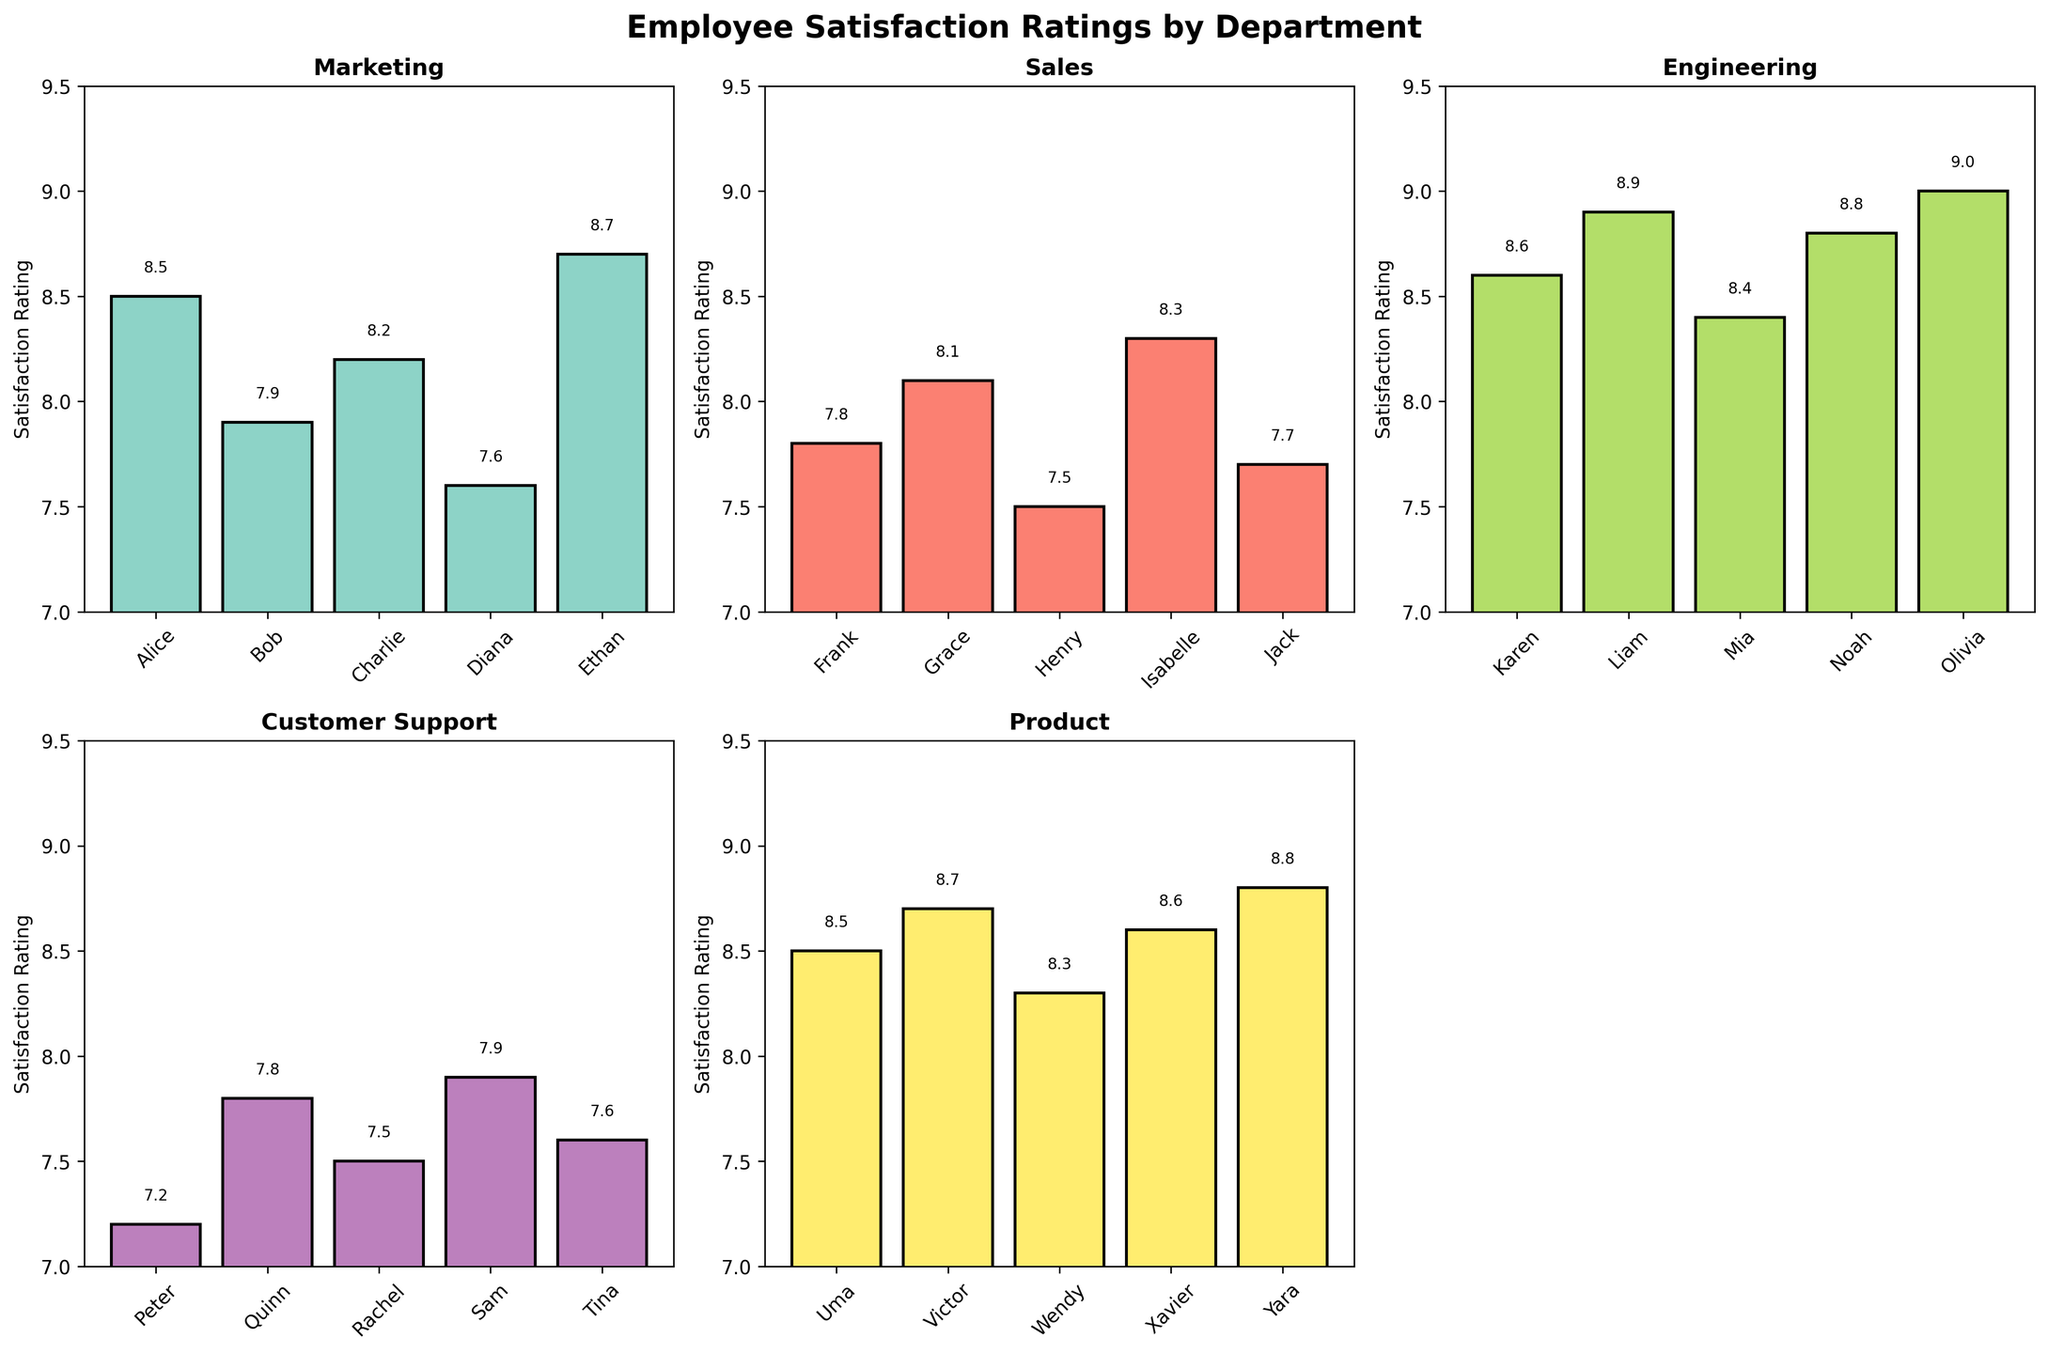Which department has the highest average satisfaction rating? Calculate the average satisfaction rating for each department: Marketing (8.18), Sales (7.88), Engineering (8.74), Customer Support (7.6), Product (8.58). Engineering has the highest average satisfaction rating.
Answer: Engineering Which employee has the highest satisfaction rating in the Customer Support department? In Customer Support, the satisfaction ratings are Peter (7.2), Quinn (7.8), Rachel (7.5), Sam (7.9), Tina (7.6). Sam has the highest rating.
Answer: Sam Compare the highest and lowest satisfaction ratings across all departments. Highest rating: Olivia in Engineering with 9.0. Lowest rating: Peter in Customer Support with 7.2.
Answer: 9.0 and 7.2 What is the difference between the average satisfaction ratings of Sales and Product departments? Calculate the averages: Sales (7.88) and Product (8.58). The difference is 8.58 - 7.88 = 0.7.
Answer: 0.7 How many departments have an average satisfaction rating above 8.5? Calculate the averages: Marketing (8.18), Sales (7.88), Engineering (8.74), Customer Support (7.6), Product (8.58). Only Engineering and Product have averages above 8.5.
Answer: 2 Which departments have at least one employee with a satisfaction rating of 8.7 or higher? Marketing: Ethan (8.7), Engineering: Liam (8.9), Noah (8.8), Olivia (9.0), Product: Uma (8.5), Victor (8.7), Yara (8.8). Engineering, Marketing, Product.
Answer: Engineering, Marketing, Product Which department has the smallest range of satisfaction ratings? Calculate the range (max - min) for each department: Marketing (8.7-7.6=1.1), Sales (8.3-7.5=0.8), Engineering (9.0-8.4=0.6), Customer Support (7.9-7.2=0.7), Product (8.8-8.3=0.5). Product has the smallest range of 0.5.
Answer: Product What's the median satisfaction rating in the Sales department? Arrange the ratings in ascending order: 7.5, 7.7, 7.8, 8.1, 8.3. The median (middle value) is 7.8.
Answer: 7.8 Which employee has the highest satisfaction rating in the Engineering department? In Engineering, the ratings are Karen (8.6), Liam (8.9), Mia (8.4), Noah (8.8), Olivia (9.0). Olivia has the highest rating with 9.0.
Answer: Olivia 